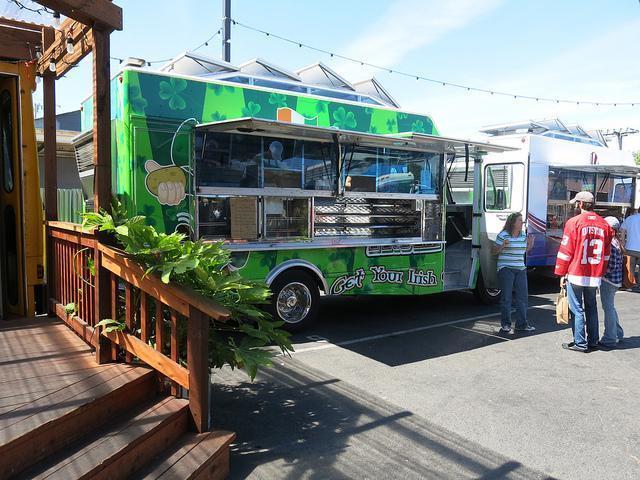How many people are there?
Give a very brief answer. 2. How many trucks are there?
Give a very brief answer. 2. How many surfboards are standing up?
Give a very brief answer. 0. 